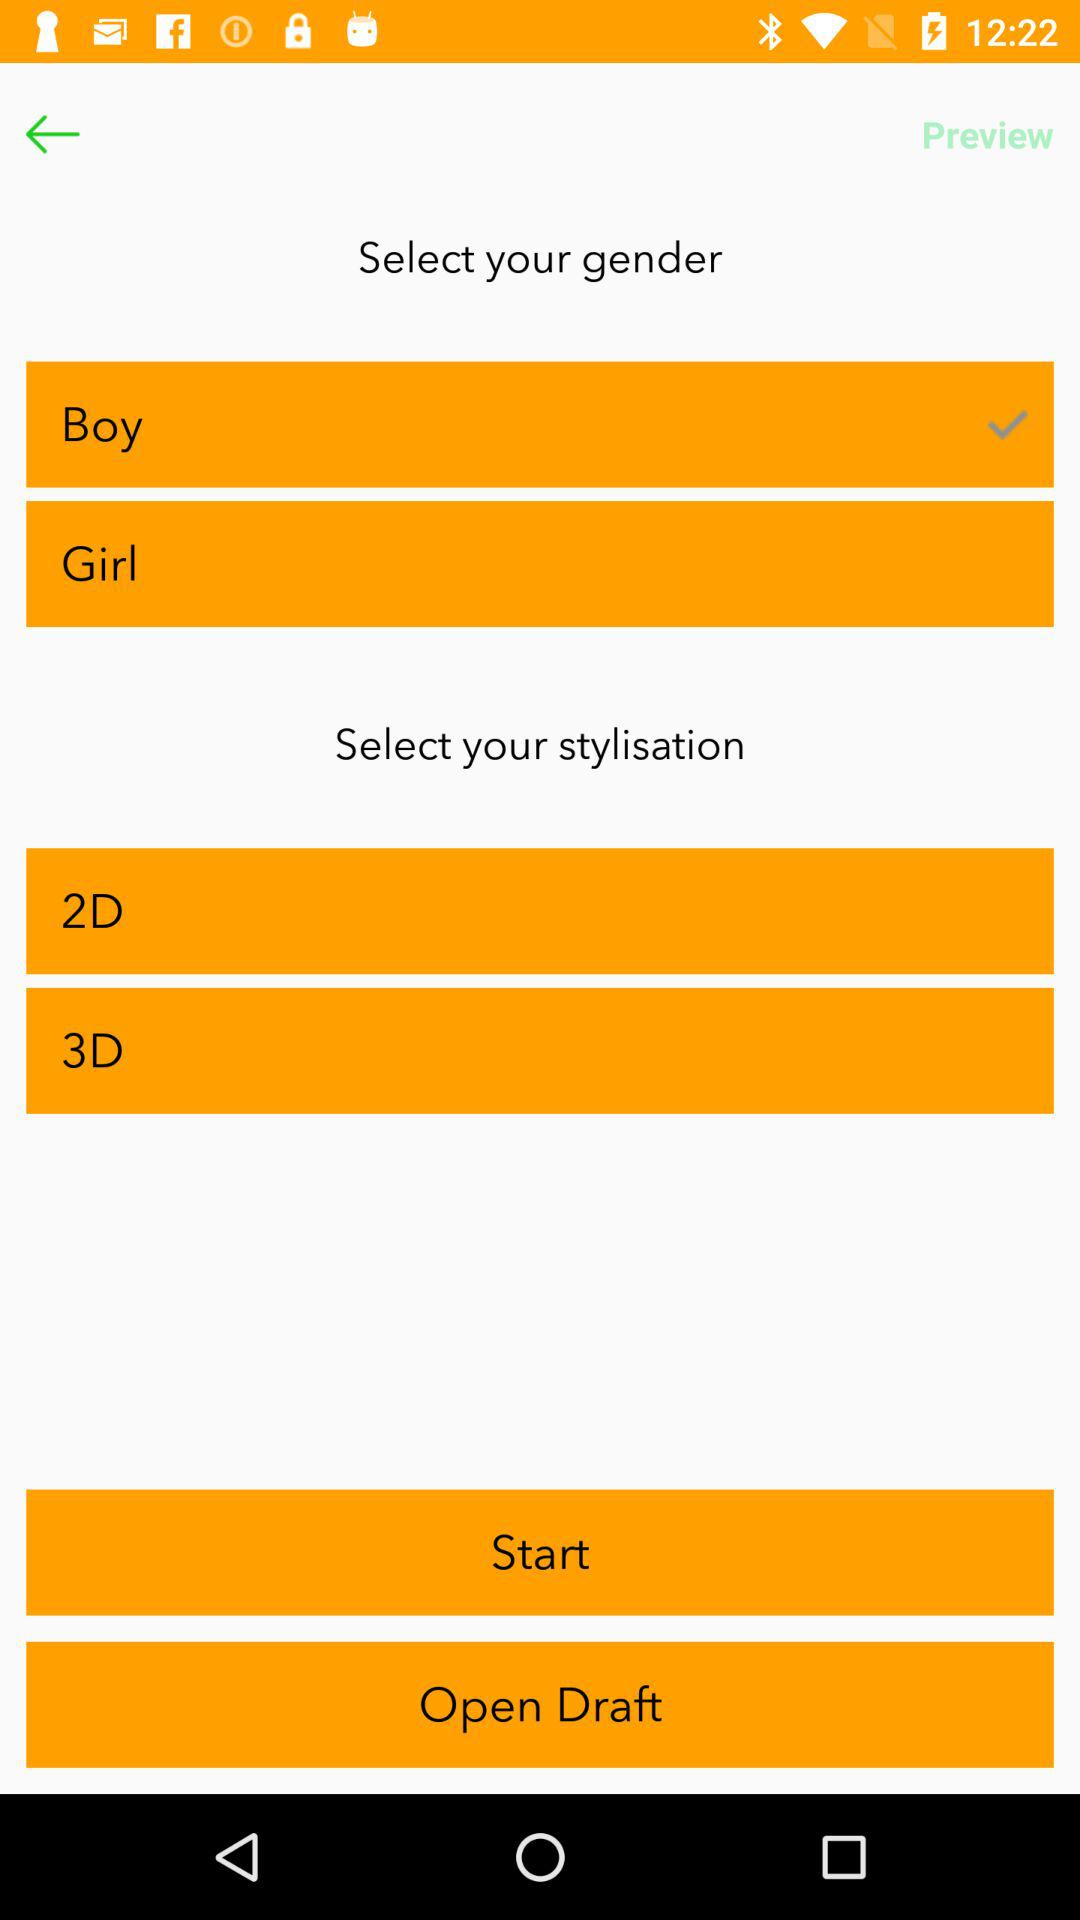What is the available stylisation? The available stylisations are "2D" and "3D". 